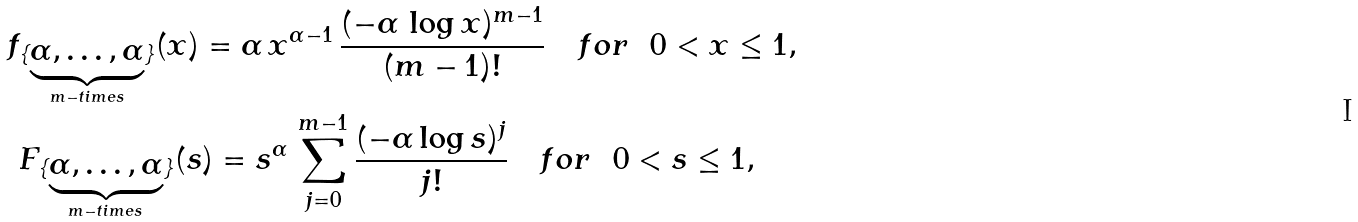Convert formula to latex. <formula><loc_0><loc_0><loc_500><loc_500>f _ { \{ \underbrace { \alpha , \dots , \alpha } _ { m - t i m e s } \} } ( x ) = \alpha \, x ^ { \alpha - 1 } \, \frac { ( - \alpha \, \log x ) ^ { m - 1 } } { ( m - 1 ) ! } \quad f o r \ \ 0 < x \leq 1 , \\ F _ { \{ \underbrace { \alpha , \dots , \alpha } _ { m - t i m e s } \} } ( s ) = s ^ { \alpha } \, \sum _ { j = 0 } ^ { m - 1 } \frac { ( - \alpha \log s ) ^ { j } } { j ! } \ \ \ f o r \ \ 0 < s \leq 1 , \quad \</formula> 